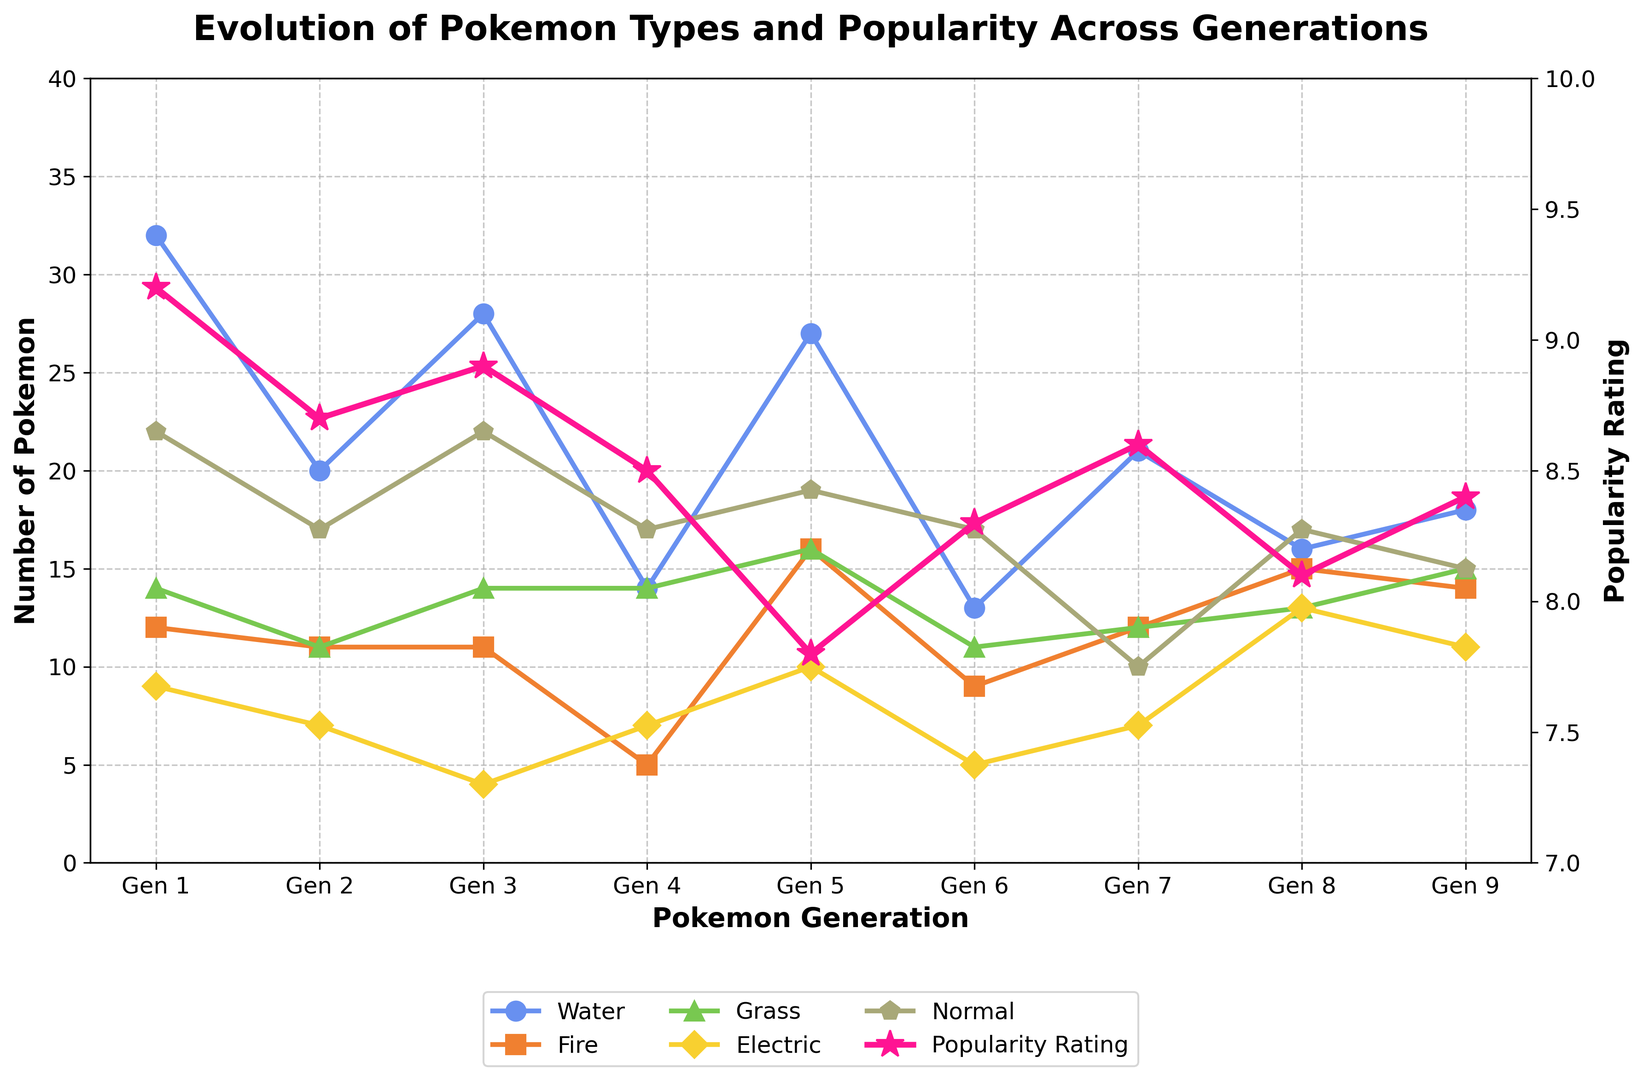Which generation has the highest number of Water-type Pokemon? Look at the curve for Water-type Pokemon and find the peak value's generation. Gen 1 has the highest value with 32 Water-type Pokemon.
Answer: Gen 1 How does the number of Fire-type Pokemon change from Gen 5 to Gen 6? Observe the Fire-type curve at Gen 5 and Gen 6. The number of Fire-type Pokemon decreases from 16 in Gen 5 to 9 in Gen 6.
Answer: Decreases Which generation has the lowest fan popularity rating? Look at the secondary axis representing fan popularity ratings and find the lowest point on the pink curve. Gen 5 has the lowest popularity rating of 7.8.
Answer: Gen 5 What is the difference in the number of Electric-type Pokemon between Gen 8 and Gen 2? Compare the value of Electric-type Pokemon in Gen 8 (13) and Gen 2 (7). The difference is 13 - 7 = 6.
Answer: 6 Which types of Pokemon have the same number in Gen 4? Examine the values for different types of Pokemon in Gen 4. Both Grass-type and Normal-type Pokemon have 14 each.
Answer: Grass and Normal How does the number of Grass-type Pokemon in Gen 9 compare to Gen 6? Look at the curve for Grass-type Pokemon in Gen 9 (15) and Gen 6 (11). The number of Grass-type Pokemon in Gen 9 is higher.
Answer: Higher What is the overall trend in the popularity rating from Gen 1 to Gen 9? Look at the secondary axis for fan popularity rating across generations. The popularity rating decreases from Gen 1 (9.2) to Gen 5 (7.8), then gradually increases again to Gen 9 (8.4).
Answer: Decrease then increase What is the total number of Electric-type Pokemon across all generations? Sum the values for Electric-type Pokemon across all generations: 9 (Gen 1) + 7 (Gen 2) + 4 (Gen 3) + 7 (Gen 4) + 10 (Gen 5) + 5 (Gen 6) + 7 (Gen 7) + 13 (Gen 8) + 11 (Gen 9) = 73.
Answer: 73 